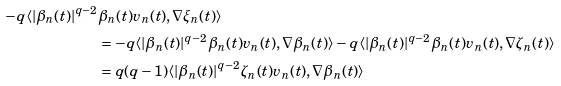Convert formula to latex. <formula><loc_0><loc_0><loc_500><loc_500>- q \langle | \beta _ { n } ( t ) | ^ { q - 2 } & \beta _ { n } ( t ) v _ { n } ( t ) , \nabla \xi _ { n } ( t ) \rangle \\ & = - q \langle | \beta _ { n } ( t ) | ^ { q - 2 } \beta _ { n } ( t ) v _ { n } ( t ) , \nabla \beta _ { n } ( t ) \rangle - q \langle | \beta _ { n } ( t ) | ^ { q - 2 } \beta _ { n } ( t ) v _ { n } ( t ) , \nabla \zeta _ { n } ( t ) \rangle \\ & = q { ( q - 1 ) } \langle | \beta _ { n } ( t ) | ^ { q - 2 } \zeta _ { n } ( t ) v _ { n } ( t ) , \nabla \beta _ { n } ( t ) \rangle</formula> 